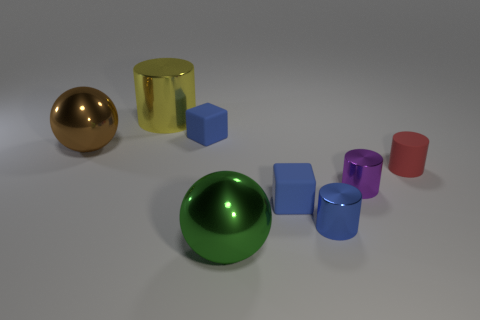Subtract 1 cylinders. How many cylinders are left? 3 Subtract all cyan cylinders. Subtract all brown spheres. How many cylinders are left? 4 Add 1 small red cylinders. How many objects exist? 9 Subtract all cubes. How many objects are left? 6 Add 5 matte things. How many matte things exist? 8 Subtract 0 yellow cubes. How many objects are left? 8 Subtract all red matte cylinders. Subtract all tiny things. How many objects are left? 2 Add 2 yellow metal cylinders. How many yellow metal cylinders are left? 3 